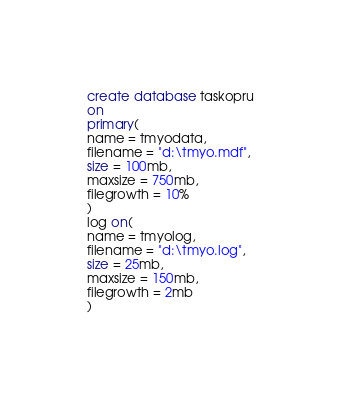<code> <loc_0><loc_0><loc_500><loc_500><_SQL_>create database taskopru
on 
primary(
name = tmyodata,
filename = "d:\tmyo.mdf",
size = 100mb,
maxsize = 750mb,
filegrowth = 10%
)
log on(
name = tmyolog,
filename = "d:\tmyo.log",
size = 25mb,
maxsize = 150mb,
filegrowth = 2mb
)</code> 